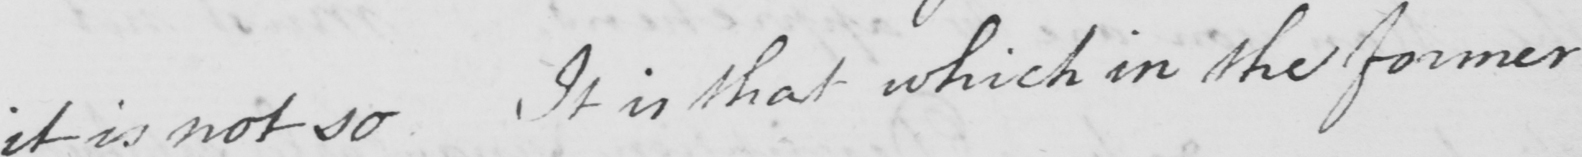Please transcribe the handwritten text in this image. it is not so . If in that which in the former 